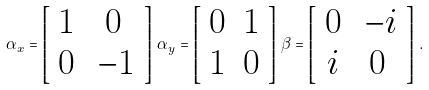Convert formula to latex. <formula><loc_0><loc_0><loc_500><loc_500>\alpha _ { x } = \left [ \begin{array} { c c } 1 & 0 \\ 0 & \, - 1 \end{array} \right ] \, \alpha _ { y } = \left [ \begin{array} { c c } 0 & 1 \\ 1 & 0 \end{array} \right ] \, \beta = \left [ \begin{array} { c c } 0 & \, - i \\ i & 0 \end{array} \right ] \, .</formula> 